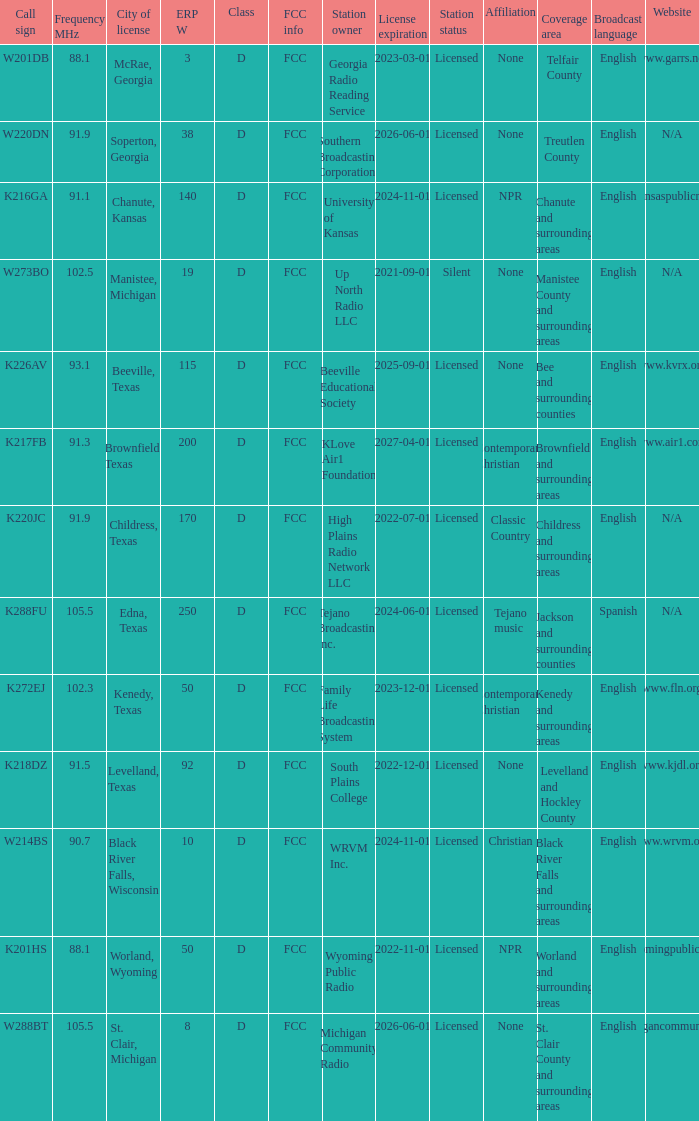What is Call Sign, when ERP W is greater than 50? K216GA, K226AV, K217FB, K220JC, K288FU, K218DZ. 